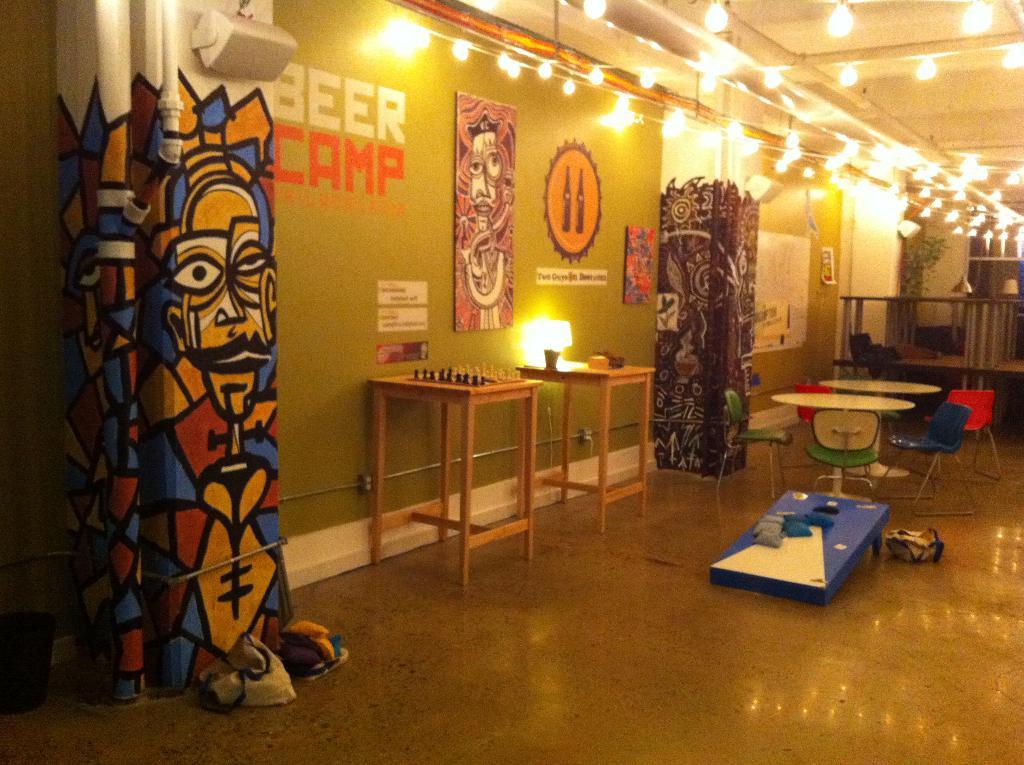What alcoholic beverage is displayed on the wall?
Your answer should be very brief. Beer. 